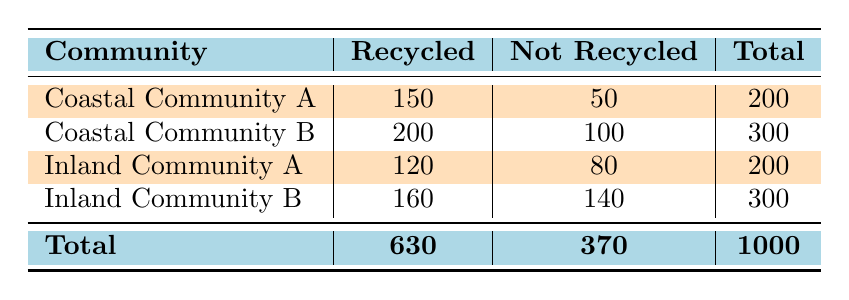What is the total number of people in Coastal Community A? In Coastal Community A, the count for "Recycled" is 150 and the count for "Not Recycled" is 50. Adding these two values together gives 150 + 50 = 200.
Answer: 200 How many more people in Coastal Communities recycled compared to Inland Communities? The total number of people who recycled in the Coastal Communities is 150 + 200 = 350. In the Inland Communities, the total who recycled is 120 + 160 = 280. The difference is 350 - 280 = 70.
Answer: 70 What is the recycling rate for Inland Community A? The recycling rate is calculated by taking the number of recycled (120) and dividing it by the total (200). So the rate is 120 / 200 = 0.6 or 60%.
Answer: 60% Did Coastal Community B have more people recycle than Inland Community A? In Coastal Community B, the count of recycled is 200, while in Inland Community A, it is 120. Since 200 is greater than 120, the statement is true.
Answer: Yes What is the total number of people who did not recycle in all communities? To find this total, add the counts for "Not Recycled" from all communities: 50 (Coastal A) + 100 (Coastal B) + 80 (Inland A) + 140 (Inland B) = 370.
Answer: 370 How many people recycled in the two Coastal Communities combined? The sum of people who recycled in the Coastal Communities is 150 (Coastal A) + 200 (Coastal B) = 350.
Answer: 350 Is the total number of people who recycled in both Inland Communities greater than 300? The total number of recycled in both Inland Communities is 120 (Inland A) + 160 (Inland B) = 280. Since 280 is less than 300, the statement is false.
Answer: No What percentage of the total surveyed considered recycling in Coastal Community A? The total from Coastal Community A is 200 (150 recycled + 50 not recycled). To find the percentage, divide 200 by the overall total of 1000 and multiply by 100, giving (200 / 1000) * 100 = 20%.
Answer: 20% What is the average number of people who did not recycle in the Inland Communities? The total number of people who did not recycle in the Inland Communities is 80 (Inland A) + 140 (Inland B) = 220. There are 2 Inland Communities, so average is 220 / 2 = 110.
Answer: 110 